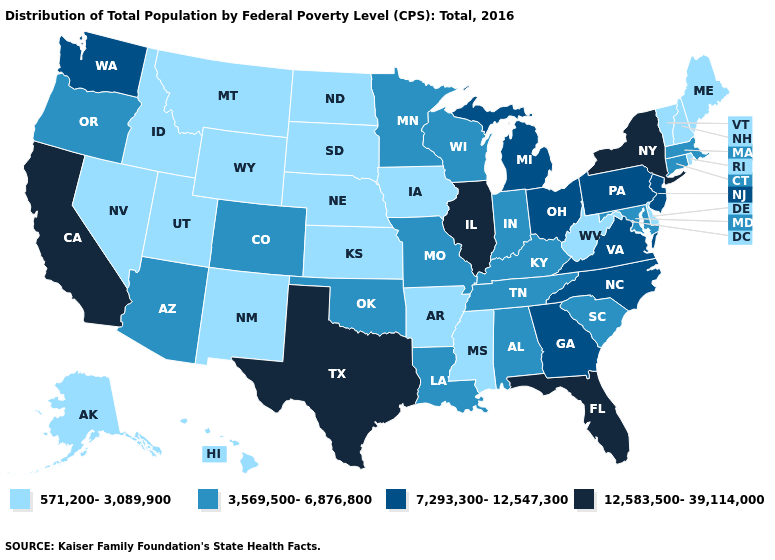Among the states that border New Hampshire , which have the lowest value?
Be succinct. Maine, Vermont. How many symbols are there in the legend?
Give a very brief answer. 4. Does Texas have the same value as Illinois?
Quick response, please. Yes. What is the highest value in the USA?
Write a very short answer. 12,583,500-39,114,000. What is the value of Maine?
Short answer required. 571,200-3,089,900. Among the states that border Utah , does Colorado have the lowest value?
Give a very brief answer. No. Name the states that have a value in the range 3,569,500-6,876,800?
Keep it brief. Alabama, Arizona, Colorado, Connecticut, Indiana, Kentucky, Louisiana, Maryland, Massachusetts, Minnesota, Missouri, Oklahoma, Oregon, South Carolina, Tennessee, Wisconsin. What is the value of Utah?
Concise answer only. 571,200-3,089,900. Name the states that have a value in the range 571,200-3,089,900?
Be succinct. Alaska, Arkansas, Delaware, Hawaii, Idaho, Iowa, Kansas, Maine, Mississippi, Montana, Nebraska, Nevada, New Hampshire, New Mexico, North Dakota, Rhode Island, South Dakota, Utah, Vermont, West Virginia, Wyoming. What is the lowest value in the USA?
Keep it brief. 571,200-3,089,900. What is the value of Nevada?
Be succinct. 571,200-3,089,900. Name the states that have a value in the range 7,293,300-12,547,300?
Be succinct. Georgia, Michigan, New Jersey, North Carolina, Ohio, Pennsylvania, Virginia, Washington. What is the lowest value in states that border Colorado?
Concise answer only. 571,200-3,089,900. What is the value of New York?
Answer briefly. 12,583,500-39,114,000. What is the value of Kansas?
Answer briefly. 571,200-3,089,900. 